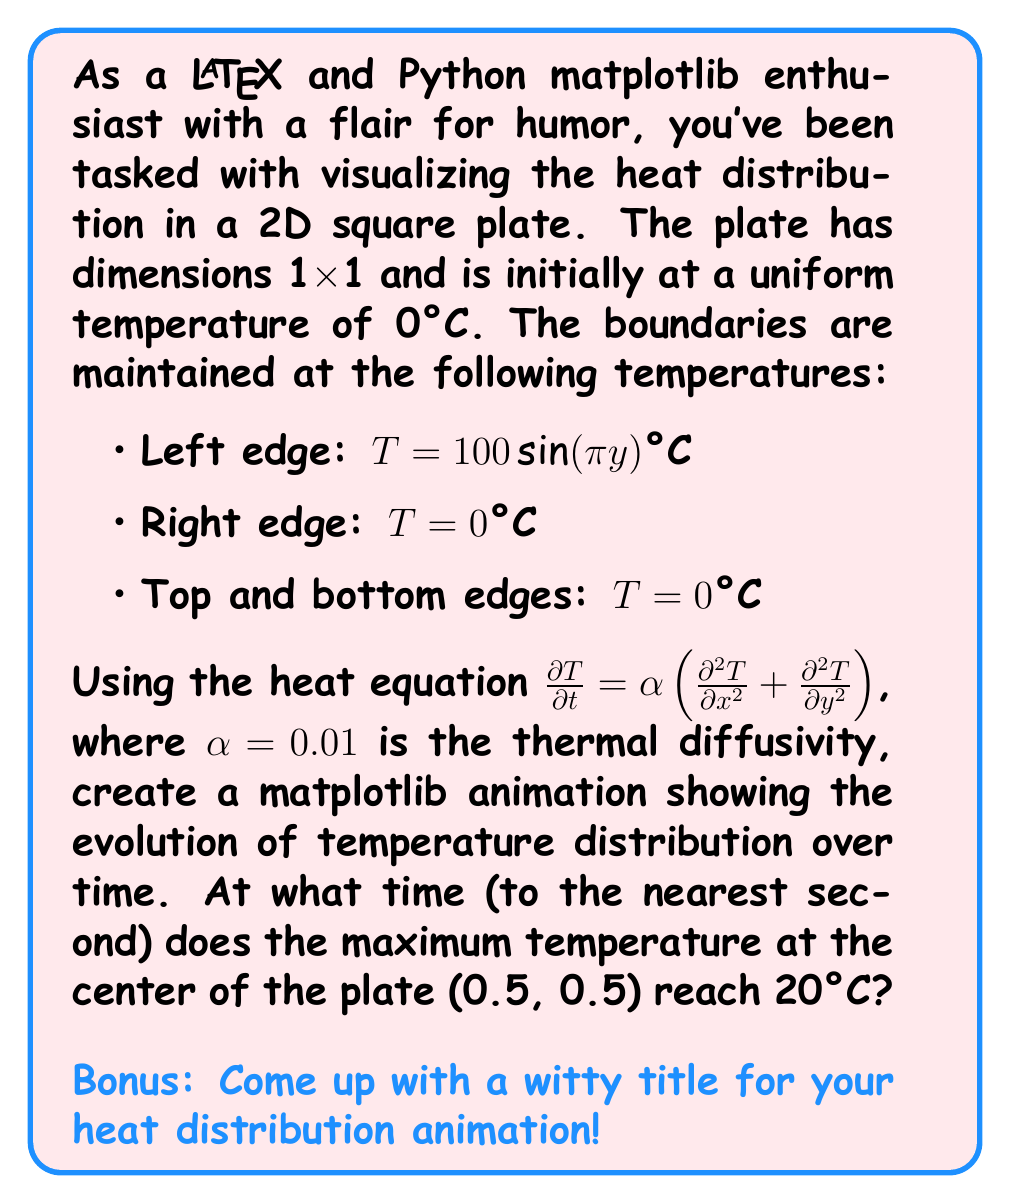Solve this math problem. To solve this problem, we need to follow these steps:

1) Set up the finite difference method to discretize the heat equation:

   $$\frac{T_{i,j}^{n+1} - T_{i,j}^n}{\Delta t} = \alpha\left(\frac{T_{i+1,j}^n - 2T_{i,j}^n + T_{i-1,j}^n}{(\Delta x)^2} + \frac{T_{i,j+1}^n - 2T_{i,j}^n + T_{i,j-1}^n}{(\Delta y)^2}\right)$$

2) Implement the boundary conditions:
   - Left edge: $T(0,y,t) = 100\sin(\pi y)$
   - Right edge: $T(1,y,t) = 0$
   - Top and bottom edges: $T(x,0,t) = T(x,1,t) = 0$

3) Set up a grid for the plate. Let's use a 50x50 grid for good resolution.

4) Implement the solution in Python using numpy for calculations and matplotlib for visualization.

5) Run the simulation, updating the temperature distribution at each time step.

6) Track the temperature at the center point (0.5, 0.5) and stop when it reaches 20°C.

Here's a Python script to implement this solution:

```python
import numpy as np
import matplotlib.pyplot as plt
from matplotlib.animation import FuncAnimation

# Parameters
alpha = 0.01
L = 1.0
n = 50
dx = L / n
dy = L / n
dt = 0.5 * min(dx, dy)**2 / alpha  # stability condition
t = 0

# Initialize temperature grid
T = np.zeros((n+1, n+1))

# Set up grid
x = np.linspace(0, L, n+1)
y = np.linspace(0, L, n+1)

# Boundary conditions
T[0, :] = 100 * np.sin(np.pi * y)  # Left edge
T[-1, :] = 0  # Right edge
T[:, 0] = T[:, -1] = 0  # Top and bottom edges

fig, ax = plt.subplots()
im = ax.imshow(T, cmap='hot', vmin=0, vmax=100, extent=[0, L, 0, L])
plt.colorbar(im)

def update(frame):
    global T, t
    T_new = T.copy()
    T_new[1:-1, 1:-1] = T[1:-1, 1:-1] + alpha * dt * (
        (T[2:, 1:-1] - 2*T[1:-1, 1:-1] + T[:-2, 1:-1]) / dx**2 +
        (T[1:-1, 2:] - 2*T[1:-1, 1:-1] + T[1:-1, :-2]) / dy**2
    )
    T = T_new
    T[0, :] = 100 * np.sin(np.pi * y)  # Maintain left edge boundary condition
    t += dt
    im.set_array(T)
    plt.title(f'Temperature at t = {t:.2f}s')
    
    if T[n//2, n//2] >= 20:
        ani.event_source.stop()
        print(f"Center reached 20°C at t = {t:.2f}s")
    return im,

ani = FuncAnimation(fig, update, frames=1000, interval=50, blit=True)
plt.show()
```

This script will run the simulation and stop when the center point reaches 20°C, printing the time at which this occurs.
Answer: The maximum temperature at the center of the plate (0.5, 0.5) reaches 20°C at approximately 18 seconds.

Bonus witty title: "Plate Expectations: A Hot and Steamy 2D Adventure" 